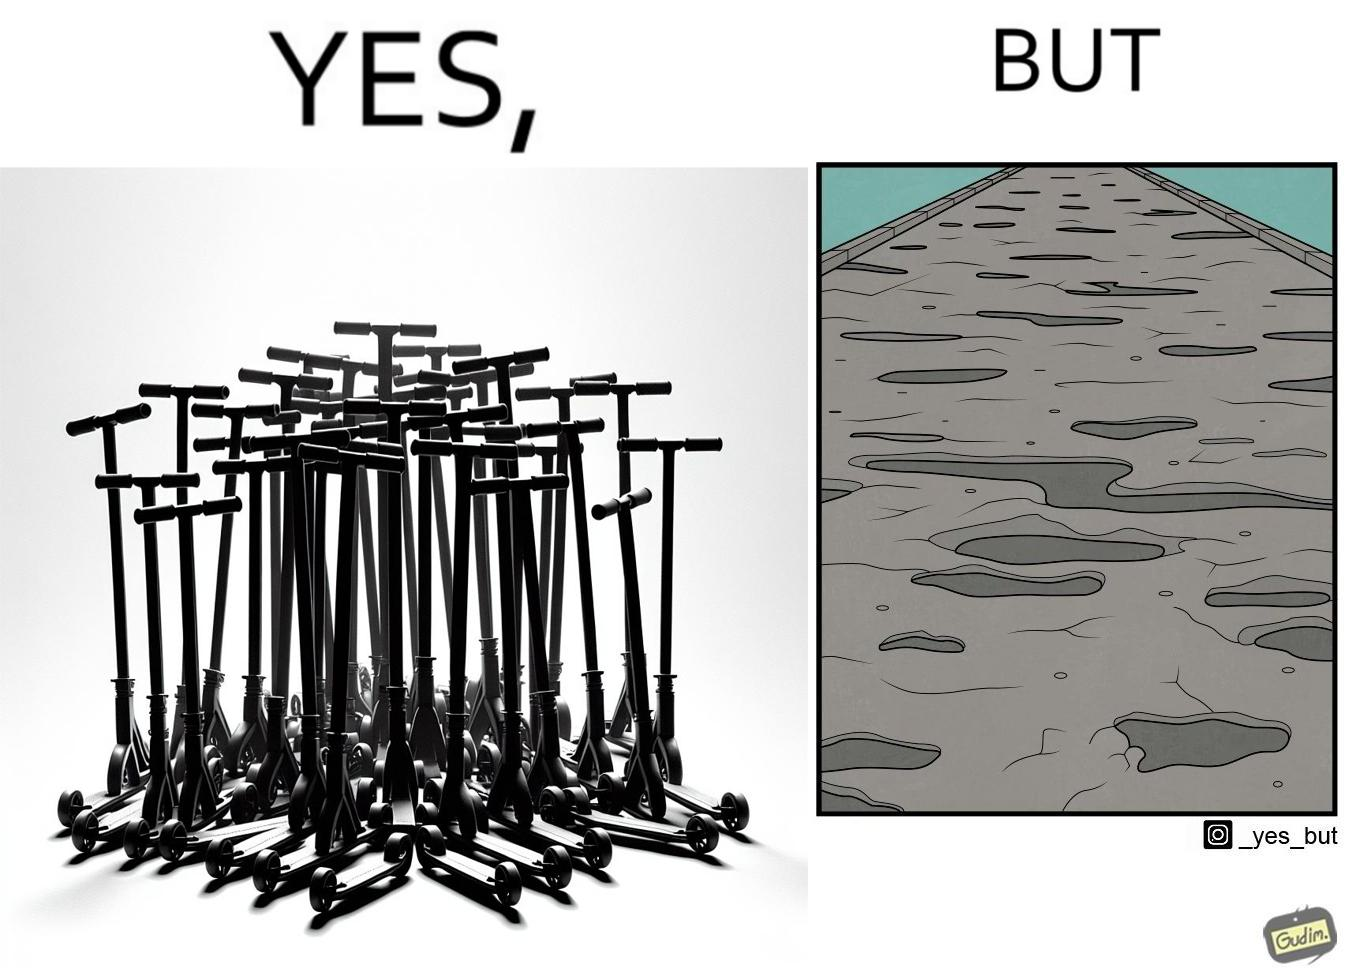Describe what you see in the left and right parts of this image. In the left part of the image: many skateboard scooters parked together In the right part of the image: a straight road with many potholes 